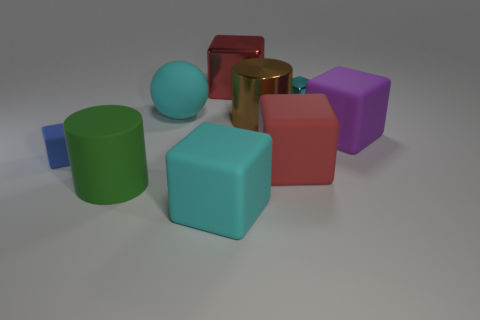Subtract all brown spheres. How many red blocks are left? 2 Subtract 3 cubes. How many cubes are left? 3 Subtract all small blue cubes. How many cubes are left? 5 Add 1 big red blocks. How many objects exist? 10 Subtract all cyan cubes. How many cubes are left? 4 Add 7 big cyan matte spheres. How many big cyan matte spheres exist? 8 Subtract 0 gray cylinders. How many objects are left? 9 Subtract all cylinders. How many objects are left? 7 Subtract all yellow spheres. Subtract all cyan cubes. How many spheres are left? 1 Subtract all large cyan objects. Subtract all cyan objects. How many objects are left? 4 